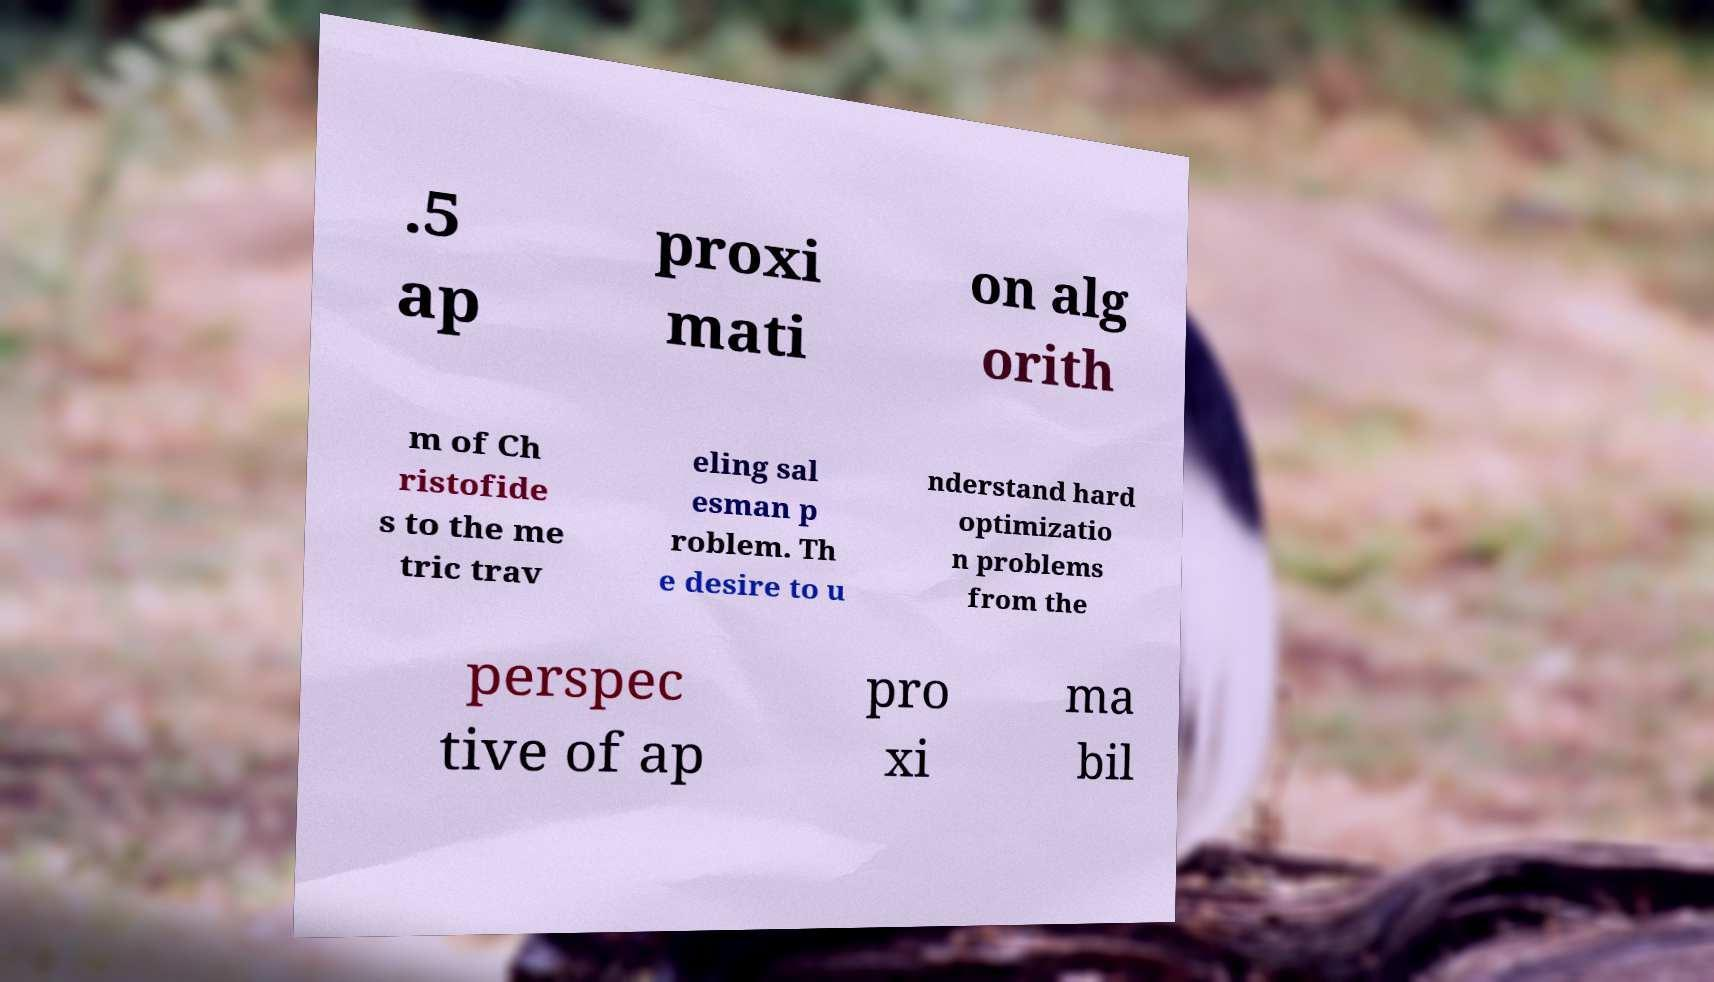Can you accurately transcribe the text from the provided image for me? .5 ap proxi mati on alg orith m of Ch ristofide s to the me tric trav eling sal esman p roblem. Th e desire to u nderstand hard optimizatio n problems from the perspec tive of ap pro xi ma bil 